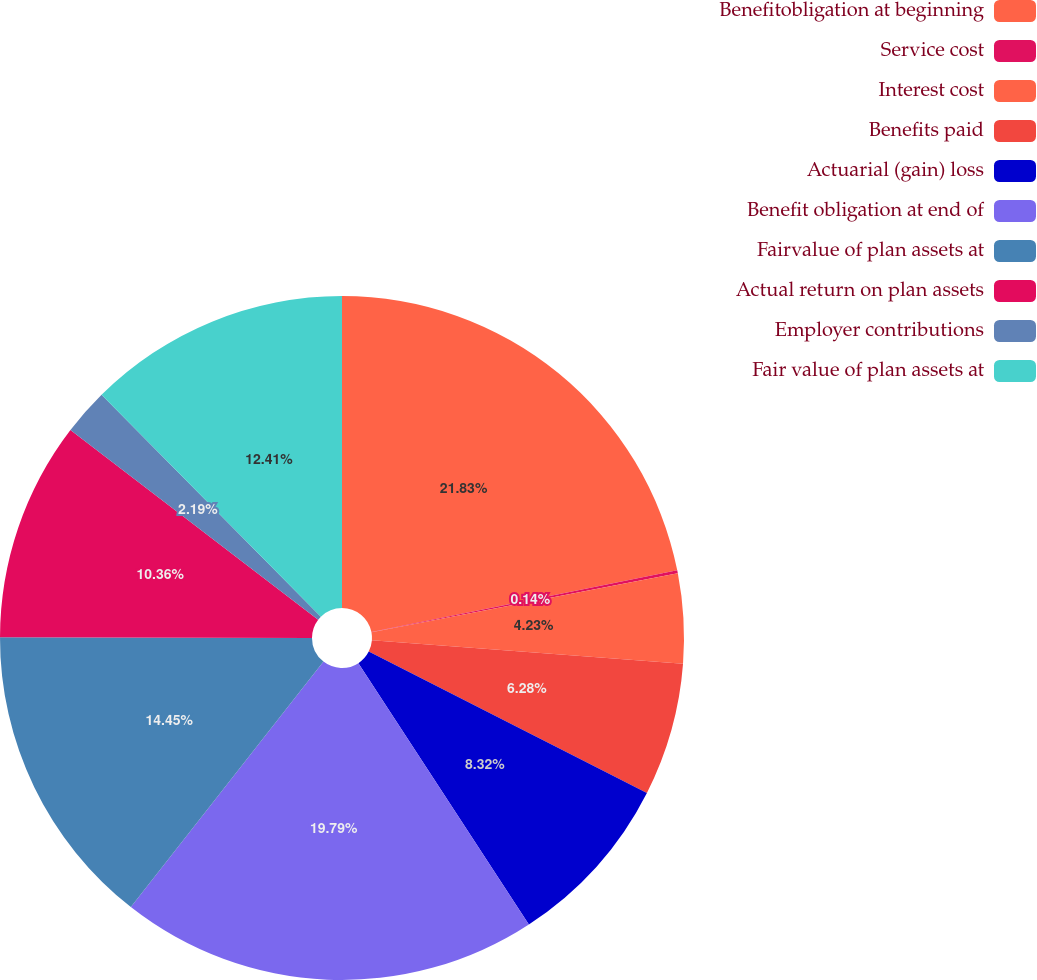Convert chart. <chart><loc_0><loc_0><loc_500><loc_500><pie_chart><fcel>Benefitobligation at beginning<fcel>Service cost<fcel>Interest cost<fcel>Benefits paid<fcel>Actuarial (gain) loss<fcel>Benefit obligation at end of<fcel>Fairvalue of plan assets at<fcel>Actual return on plan assets<fcel>Employer contributions<fcel>Fair value of plan assets at<nl><fcel>21.83%<fcel>0.14%<fcel>4.23%<fcel>6.28%<fcel>8.32%<fcel>19.79%<fcel>14.45%<fcel>10.36%<fcel>2.19%<fcel>12.41%<nl></chart> 